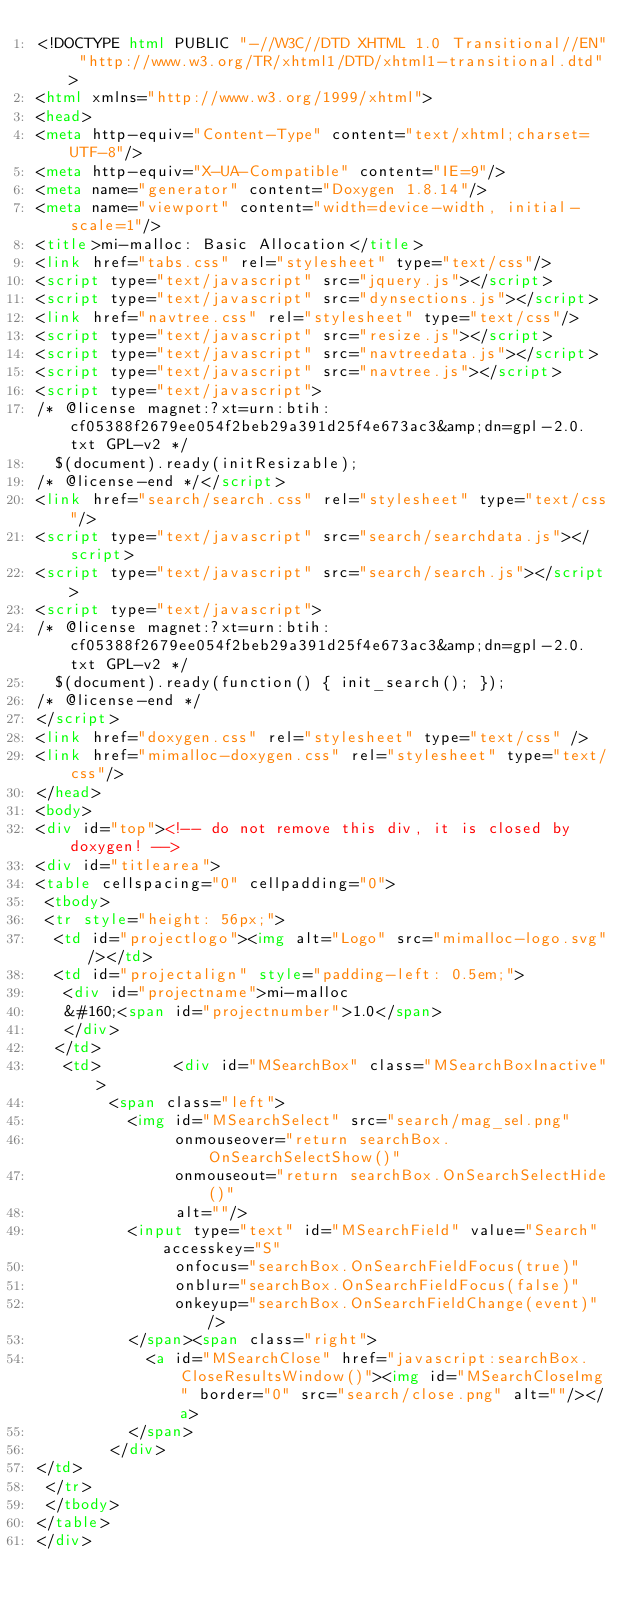<code> <loc_0><loc_0><loc_500><loc_500><_HTML_><!DOCTYPE html PUBLIC "-//W3C//DTD XHTML 1.0 Transitional//EN" "http://www.w3.org/TR/xhtml1/DTD/xhtml1-transitional.dtd">
<html xmlns="http://www.w3.org/1999/xhtml">
<head>
<meta http-equiv="Content-Type" content="text/xhtml;charset=UTF-8"/>
<meta http-equiv="X-UA-Compatible" content="IE=9"/>
<meta name="generator" content="Doxygen 1.8.14"/>
<meta name="viewport" content="width=device-width, initial-scale=1"/>
<title>mi-malloc: Basic Allocation</title>
<link href="tabs.css" rel="stylesheet" type="text/css"/>
<script type="text/javascript" src="jquery.js"></script>
<script type="text/javascript" src="dynsections.js"></script>
<link href="navtree.css" rel="stylesheet" type="text/css"/>
<script type="text/javascript" src="resize.js"></script>
<script type="text/javascript" src="navtreedata.js"></script>
<script type="text/javascript" src="navtree.js"></script>
<script type="text/javascript">
/* @license magnet:?xt=urn:btih:cf05388f2679ee054f2beb29a391d25f4e673ac3&amp;dn=gpl-2.0.txt GPL-v2 */
  $(document).ready(initResizable);
/* @license-end */</script>
<link href="search/search.css" rel="stylesheet" type="text/css"/>
<script type="text/javascript" src="search/searchdata.js"></script>
<script type="text/javascript" src="search/search.js"></script>
<script type="text/javascript">
/* @license magnet:?xt=urn:btih:cf05388f2679ee054f2beb29a391d25f4e673ac3&amp;dn=gpl-2.0.txt GPL-v2 */
  $(document).ready(function() { init_search(); });
/* @license-end */
</script>
<link href="doxygen.css" rel="stylesheet" type="text/css" />
<link href="mimalloc-doxygen.css" rel="stylesheet" type="text/css"/>
</head>
<body>
<div id="top"><!-- do not remove this div, it is closed by doxygen! -->
<div id="titlearea">
<table cellspacing="0" cellpadding="0">
 <tbody>
 <tr style="height: 56px;">
  <td id="projectlogo"><img alt="Logo" src="mimalloc-logo.svg"/></td>
  <td id="projectalign" style="padding-left: 0.5em;">
   <div id="projectname">mi-malloc
   &#160;<span id="projectnumber">1.0</span>
   </div>
  </td>
   <td>        <div id="MSearchBox" class="MSearchBoxInactive">
        <span class="left">
          <img id="MSearchSelect" src="search/mag_sel.png"
               onmouseover="return searchBox.OnSearchSelectShow()"
               onmouseout="return searchBox.OnSearchSelectHide()"
               alt=""/>
          <input type="text" id="MSearchField" value="Search" accesskey="S"
               onfocus="searchBox.OnSearchFieldFocus(true)" 
               onblur="searchBox.OnSearchFieldFocus(false)" 
               onkeyup="searchBox.OnSearchFieldChange(event)"/>
          </span><span class="right">
            <a id="MSearchClose" href="javascript:searchBox.CloseResultsWindow()"><img id="MSearchCloseImg" border="0" src="search/close.png" alt=""/></a>
          </span>
        </div>
</td>
 </tr>
 </tbody>
</table>
</div></code> 